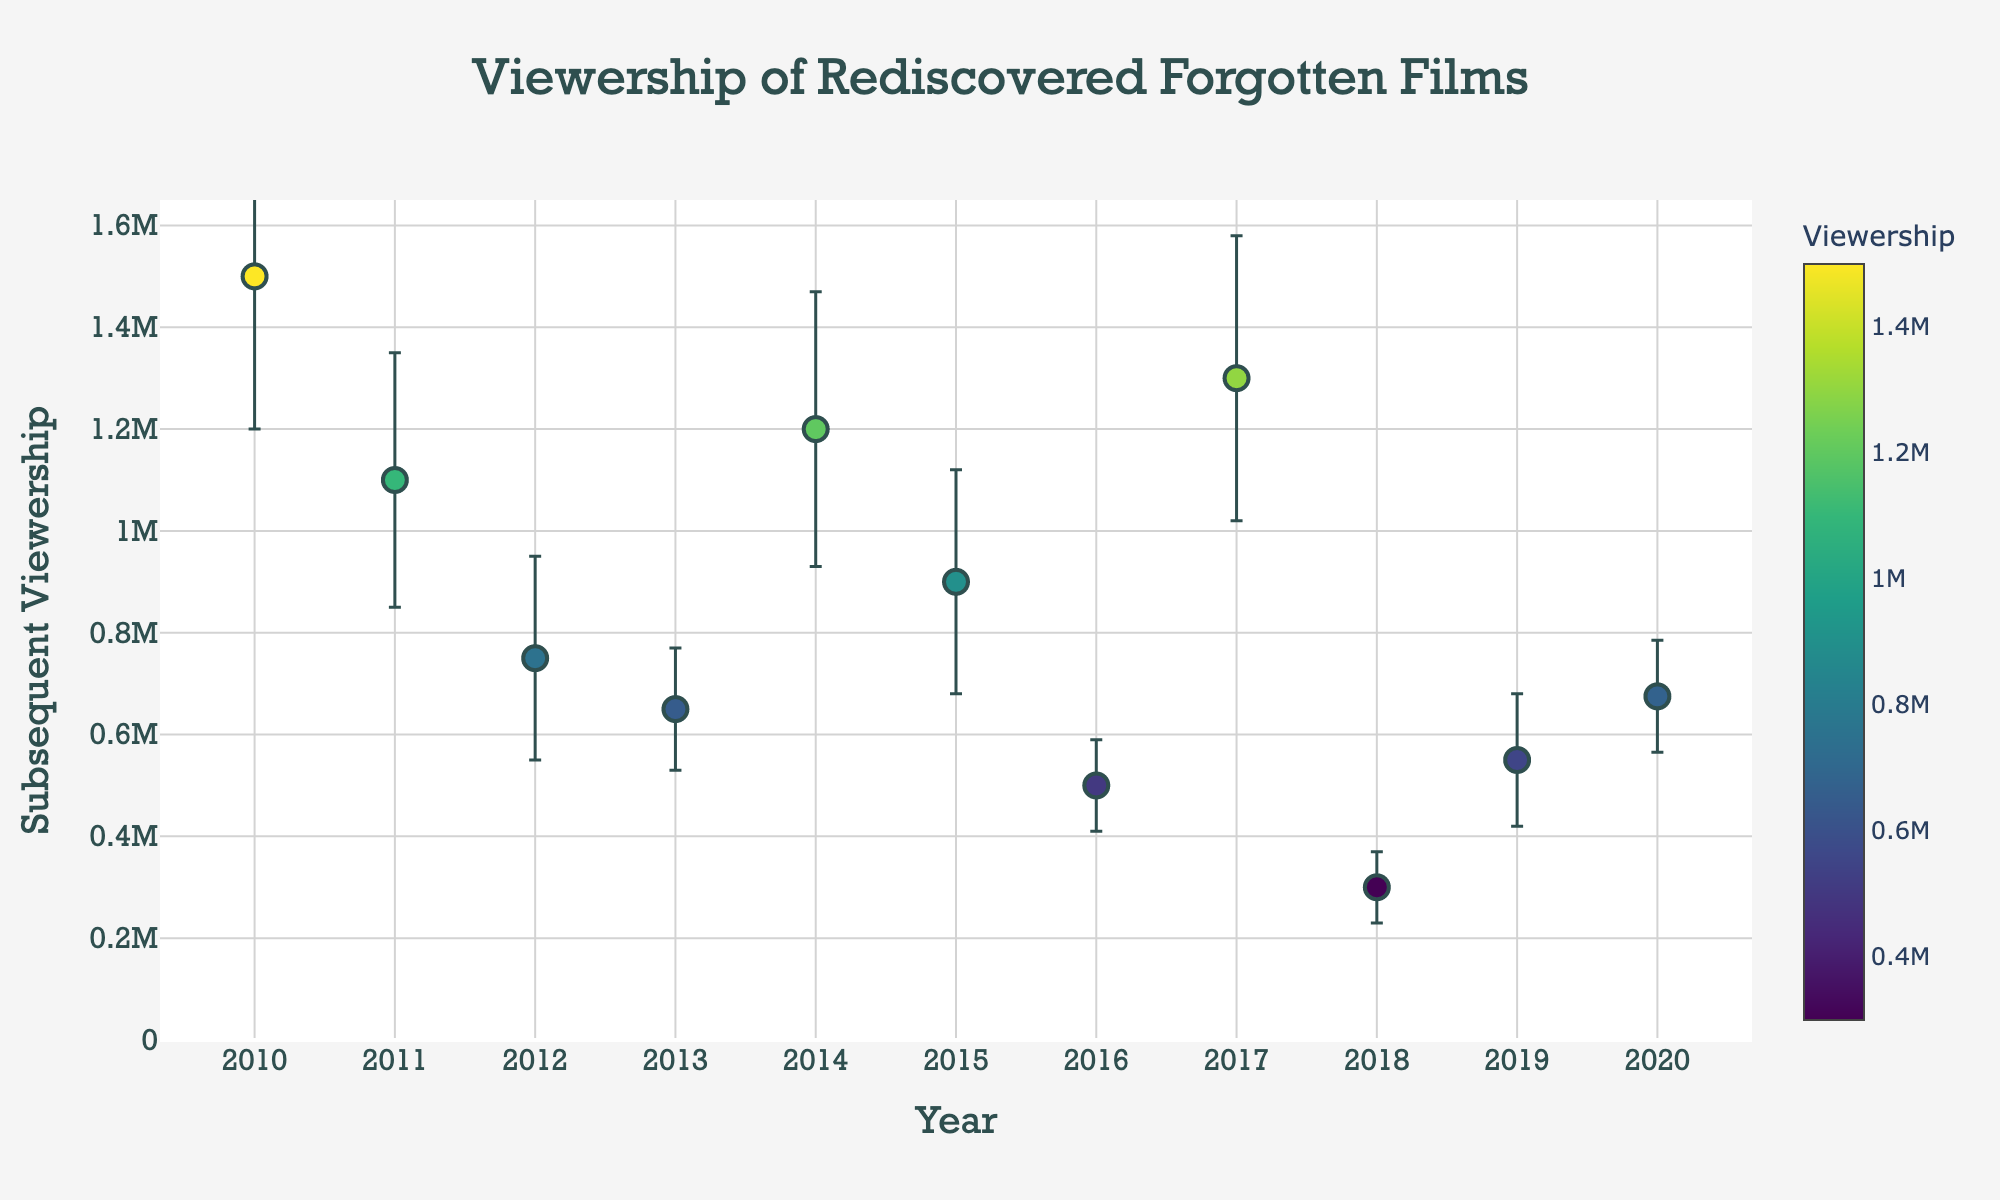What is the title of the figure? The title is located at the top center of the figure and it reads 'Viewership of Rediscovered Forgotten Films'.
Answer: Viewership of Rediscovered Forgotten Films What is the range of the 'Subsequent Viewership' axis? The range can be determined by looking at the y-axis. Here, the range goes from 0 to a bit above 1,650,000, allowing space for error bars.
Answer: 0 to approximately 1,650,000 Which film has the highest subsequent viewership and what is that viewership? Locate the highest dot on the plot and hover to find its details. This dot represents 'Metropolis' with a subsequent viewership of 1,500,000.
Answer: Metropolis with 1,500,000 Which year had the rediscovery of the film, 'The Passion of Joan of Arc'? Hover over the relevant dot (x-axis 2017) to see the film's name, which indicates that 'The Passion of Joan of Arc' was rediscovered in 2009 by Gaumont.
Answer: 2017 How many films have a subsequent viewership of over 1,000,000? Count the number of dots above the 1,000,000 mark on the y-axis. There are 4 such films.
Answer: 4 What is the average subsequent viewership for films rediscovered between 2013 and 2015? Identify and sum the subsequent viewerships for the films in 2013, 2014, and 2015, and then divide by the number of those films. \( (650,000 + 1,200,000 + 900,000) / 3 = 2,750,000 / 3 = 916,667 \)
Answer: 916,667 What is the error bar value for the film 'A Trip to Mars'? Hover over the dot corresponding to 2016, which shows 'A Trip to Mars' with an error bar indicating a standard deviation of 90,000.
Answer: 90,000 Which rediscovered film in 2018 has the smallest standard deviation in viewership, and what is its value? Locate the dot on the x-axis for the year 2018 and hover to reveal 'Begotten' with a standard deviation of 70,000. This is the smallest among the visible error bars.
Answer: Begotten with 70,000 Compare the subsequent viewership of 'L’Inferno' and 'A Trip to Mars'. Which one is higher and by how much? Locate the corresponding dots for both films, view their hover information, and subtract the subsequent viewership of 'A Trip to Mars' from 'L’Inferno'. \( 1,200,000 - 500,000 = 700,000 \)
Answer: L’Inferno by 700,000 